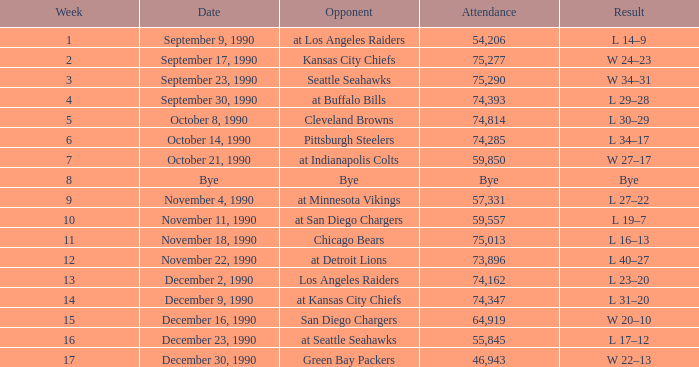How many weeks was there an attendance of 74,347? 14.0. 